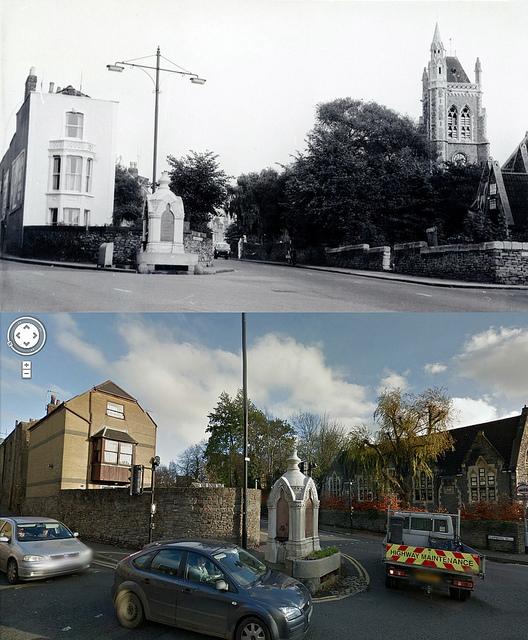How many frames appear in this scene?
Keep it brief. 2. Is the sky blue?
Answer briefly. Yes. What is the mode of transportation?
Give a very brief answer. Car. Is it likely these two scenes show a time-lapse?
Concise answer only. Yes. Why are the trees blurry?
Answer briefly. Bad picture. How many red cars are there?
Give a very brief answer. 0. How many street lights are visible?
Keep it brief. 2. Is this an urban environment?
Concise answer only. No. What type of vehicles are shown?
Answer briefly. Cars. 